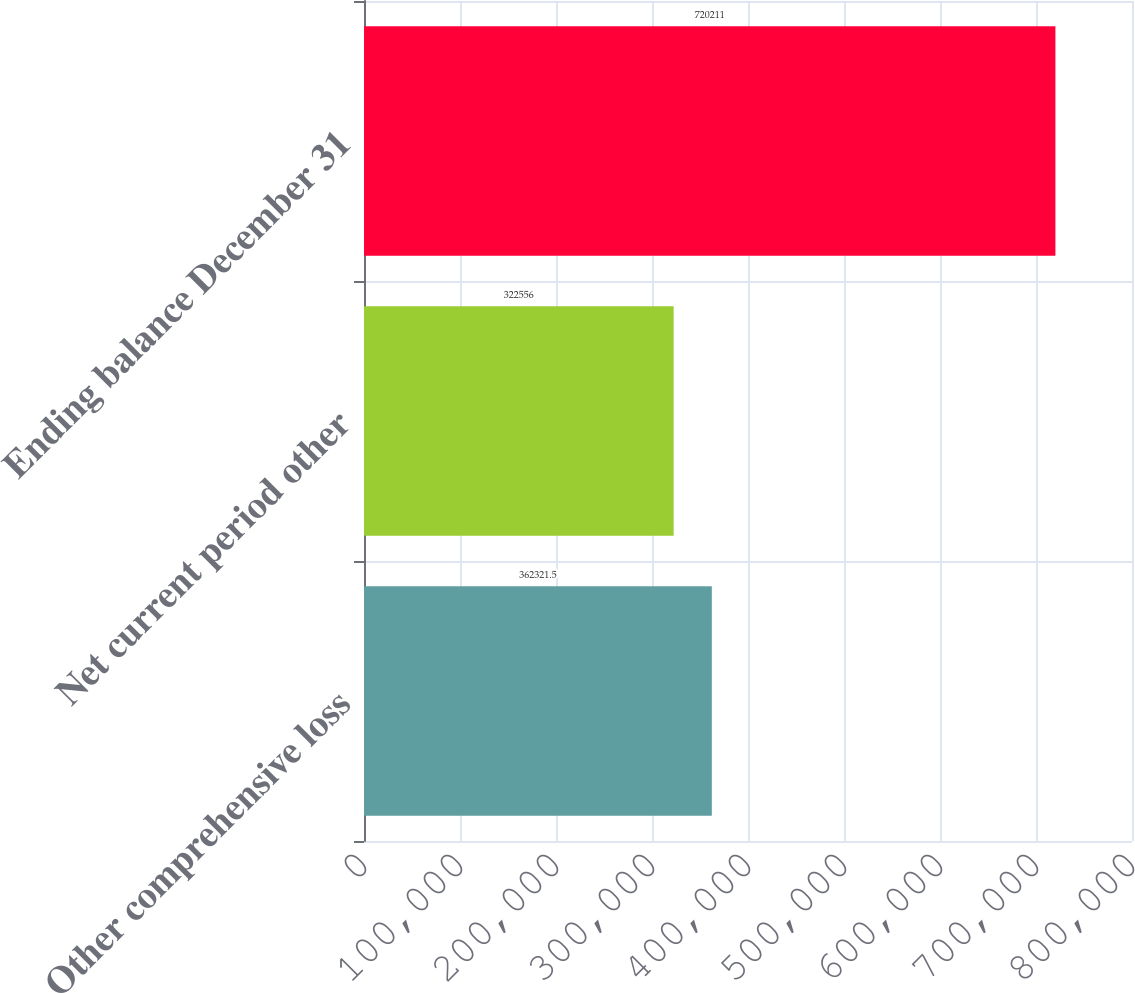<chart> <loc_0><loc_0><loc_500><loc_500><bar_chart><fcel>Other comprehensive loss<fcel>Net current period other<fcel>Ending balance December 31<nl><fcel>362322<fcel>322556<fcel>720211<nl></chart> 